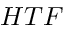Convert formula to latex. <formula><loc_0><loc_0><loc_500><loc_500>H T F</formula> 